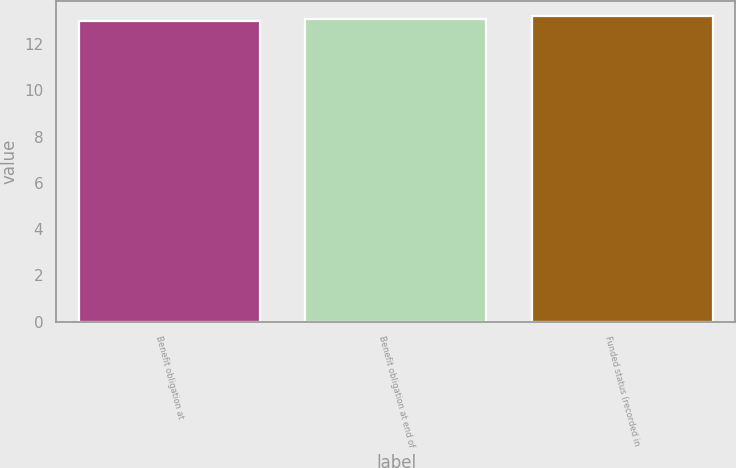Convert chart. <chart><loc_0><loc_0><loc_500><loc_500><bar_chart><fcel>Benefit obligation at<fcel>Benefit obligation at end of<fcel>Funded status (recorded in<nl><fcel>13<fcel>13.1<fcel>13.2<nl></chart> 